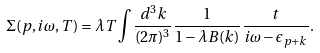<formula> <loc_0><loc_0><loc_500><loc_500>\Sigma ( p , i \omega , T ) = \lambda T \int \frac { d ^ { 3 } k } { ( 2 \pi ) ^ { 3 } } \frac { 1 } { 1 - \lambda B ( k ) } \frac { t } { i \omega - \epsilon _ { p + k } } .</formula> 